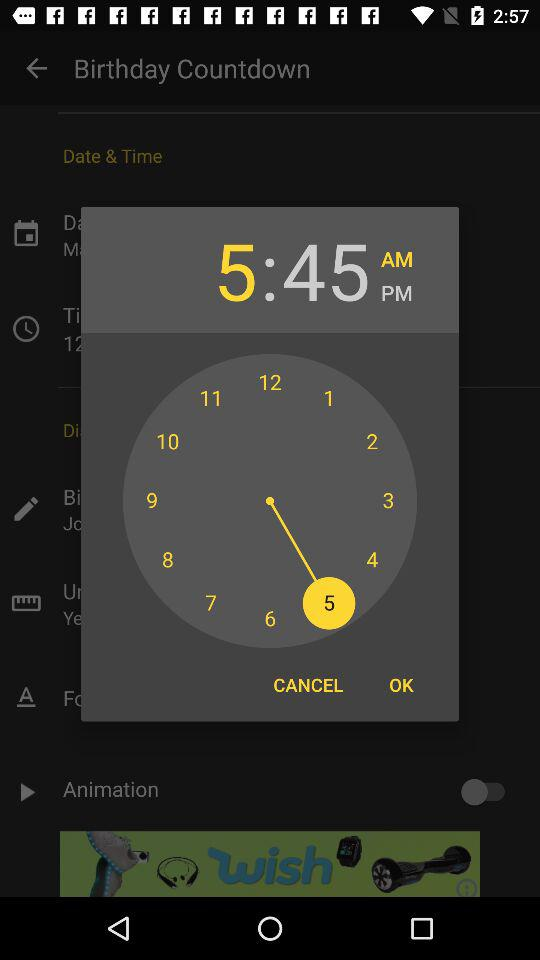What time is selected? The selected time is 5:45 AM. 